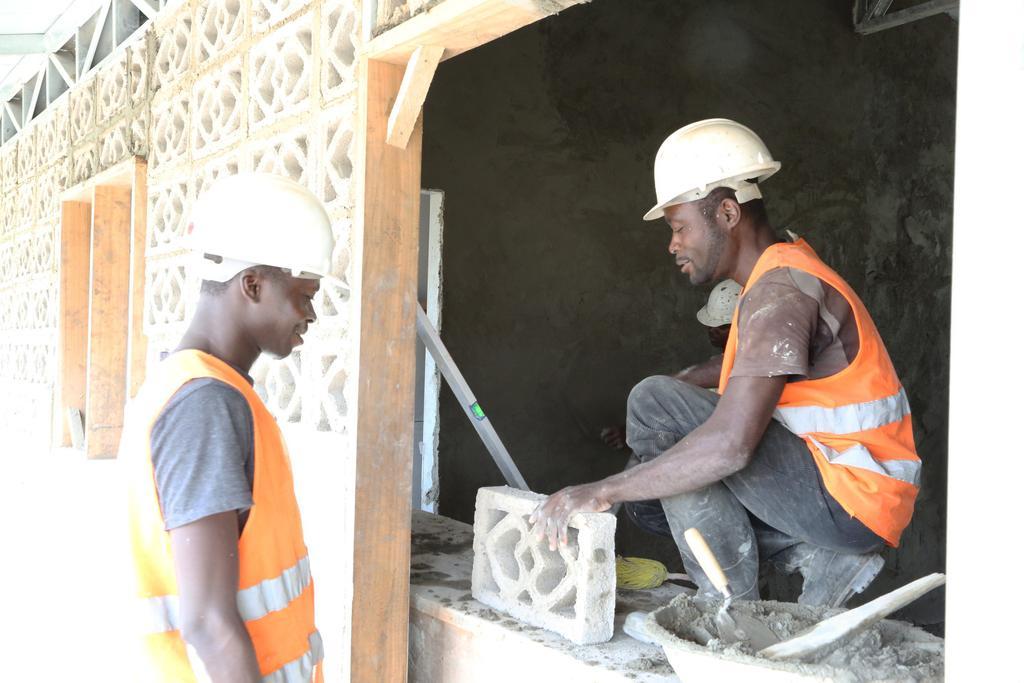Could you give a brief overview of what you see in this image? In this picture we can see there are two people standing and a person is in squat position. A person in the squat position is holding a brick. At the bottom right corner there is a trowel and some objects. Behind the people there are walls. 